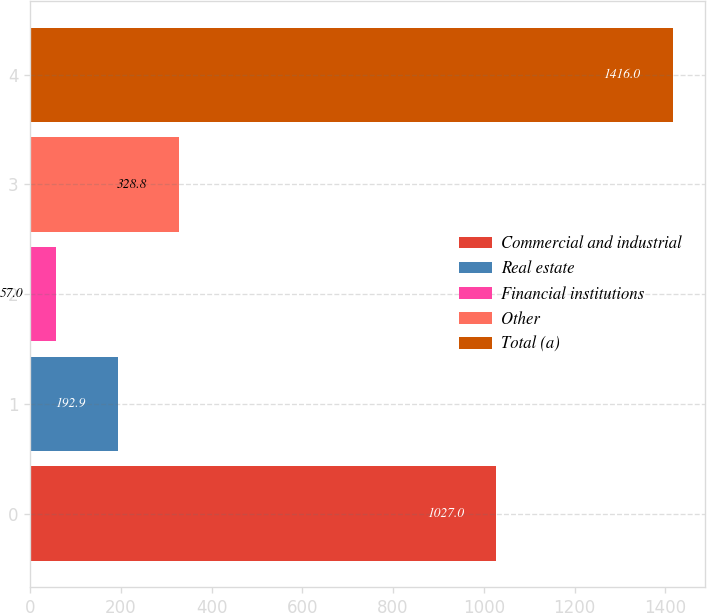Convert chart. <chart><loc_0><loc_0><loc_500><loc_500><bar_chart><fcel>Commercial and industrial<fcel>Real estate<fcel>Financial institutions<fcel>Other<fcel>Total (a)<nl><fcel>1027<fcel>192.9<fcel>57<fcel>328.8<fcel>1416<nl></chart> 